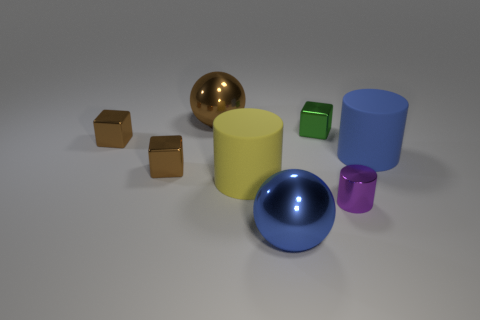Are there the same number of yellow things that are right of the small green block and small yellow balls?
Make the answer very short. Yes. There is a big metal ball that is behind the purple shiny cylinder; does it have the same color as the block in front of the large blue rubber thing?
Your response must be concise. Yes. What number of objects are left of the small purple cylinder and to the right of the brown shiny ball?
Your response must be concise. 3. How many other objects are the same shape as the large brown thing?
Your response must be concise. 1. Are there more large spheres in front of the tiny purple shiny cylinder than tiny yellow rubber things?
Your answer should be very brief. Yes. The metal block right of the blue metal sphere is what color?
Make the answer very short. Green. How many shiny objects are big blue balls or blue objects?
Ensure brevity in your answer.  1. Is there a large blue thing that is to the left of the tiny brown metal thing behind the large rubber thing that is right of the big blue metallic sphere?
Your response must be concise. No. What number of yellow cylinders are on the right side of the small green thing?
Provide a succinct answer. 0. How many big objects are cyan cylinders or blue matte cylinders?
Your answer should be compact. 1. 